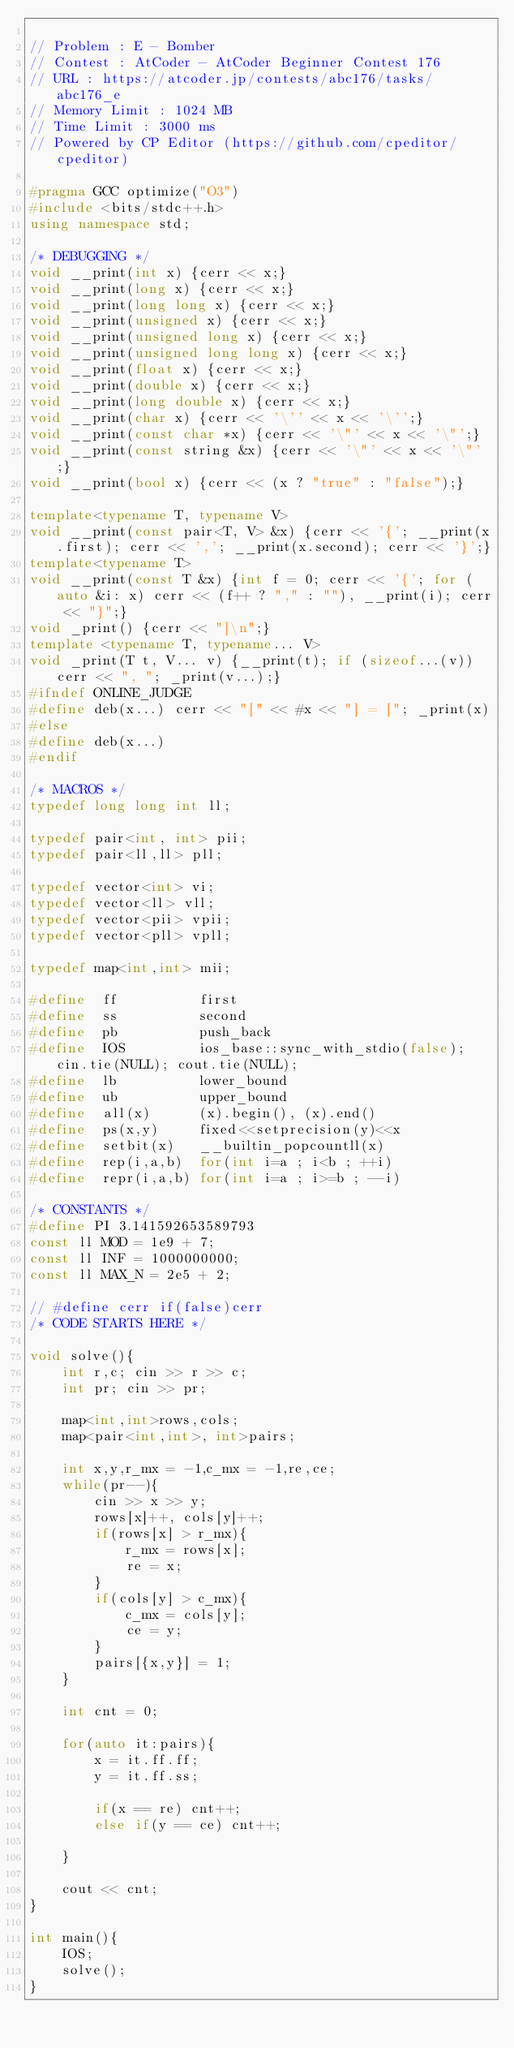<code> <loc_0><loc_0><loc_500><loc_500><_C++_>
// Problem : E - Bomber
// Contest : AtCoder - AtCoder Beginner Contest 176
// URL : https://atcoder.jp/contests/abc176/tasks/abc176_e
// Memory Limit : 1024 MB
// Time Limit : 3000 ms
// Powered by CP Editor (https://github.com/cpeditor/cpeditor)

#pragma GCC optimize("O3")
#include <bits/stdc++.h>
using namespace std;

/* DEBUGGING */
void __print(int x) {cerr << x;}
void __print(long x) {cerr << x;}
void __print(long long x) {cerr << x;}
void __print(unsigned x) {cerr << x;}
void __print(unsigned long x) {cerr << x;}
void __print(unsigned long long x) {cerr << x;}
void __print(float x) {cerr << x;}
void __print(double x) {cerr << x;}
void __print(long double x) {cerr << x;}
void __print(char x) {cerr << '\'' << x << '\'';}
void __print(const char *x) {cerr << '\"' << x << '\"';}
void __print(const string &x) {cerr << '\"' << x << '\"';}
void __print(bool x) {cerr << (x ? "true" : "false");}

template<typename T, typename V>
void __print(const pair<T, V> &x) {cerr << '{'; __print(x.first); cerr << ','; __print(x.second); cerr << '}';}
template<typename T>
void __print(const T &x) {int f = 0; cerr << '{'; for (auto &i: x) cerr << (f++ ? "," : ""), __print(i); cerr << "}";}
void _print() {cerr << "]\n";}
template <typename T, typename... V>
void _print(T t, V... v) {__print(t); if (sizeof...(v)) cerr << ", "; _print(v...);}
#ifndef ONLINE_JUDGE
#define deb(x...) cerr << "[" << #x << "] = ["; _print(x)
#else
#define deb(x...)
#endif

/* MACROS */ 
typedef long long int ll;
 
typedef pair<int, int> pii;
typedef pair<ll,ll> pll;
 
typedef vector<int> vi;
typedef vector<ll> vll;
typedef vector<pii> vpii;
typedef vector<pll> vpll;

typedef map<int,int> mii;

#define  ff          first
#define  ss          second
#define  pb          push_back
#define  IOS         ios_base::sync_with_stdio(false); cin.tie(NULL); cout.tie(NULL);
#define  lb          lower_bound
#define  ub          upper_bound
#define  all(x)      (x).begin(), (x).end()
#define  ps(x,y)     fixed<<setprecision(y)<<x
#define  setbit(x)   __builtin_popcountll(x)
#define  rep(i,a,b)  for(int i=a ; i<b ; ++i)
#define  repr(i,a,b) for(int i=a ; i>=b ; --i)

/* CONSTANTS */ 
#define PI 3.141592653589793
const ll MOD = 1e9 + 7;
const ll INF = 1000000000;
const ll MAX_N = 2e5 + 2;

// #define cerr if(false)cerr
/* CODE STARTS HERE */

void solve(){
    int r,c; cin >> r >> c;
    int pr; cin >> pr;
    
    map<int,int>rows,cols;
    map<pair<int,int>, int>pairs;
    
    int x,y,r_mx = -1,c_mx = -1,re,ce;
    while(pr--){
        cin >> x >> y;
        rows[x]++, cols[y]++;
        if(rows[x] > r_mx){
            r_mx = rows[x];
            re = x;
        }
        if(cols[y] > c_mx){
            c_mx = cols[y];
            ce = y;
        }
        pairs[{x,y}] = 1;
    }
    
    int cnt = 0;
    
    for(auto it:pairs){
        x = it.ff.ff;
        y = it.ff.ss;
        
        if(x == re) cnt++;            
        else if(y == ce) cnt++;
        
    }
    
    cout << cnt;
}

int main(){
    IOS;
    solve();
}</code> 